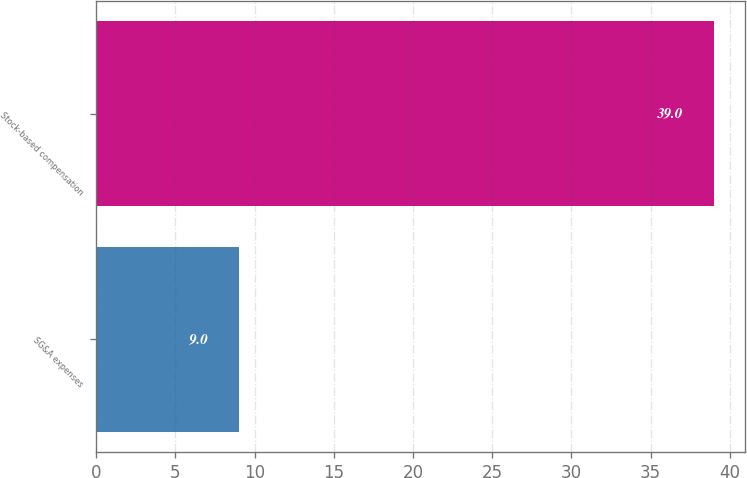Convert chart. <chart><loc_0><loc_0><loc_500><loc_500><bar_chart><fcel>SG&A expenses<fcel>Stock-based compensation<nl><fcel>9<fcel>39<nl></chart> 